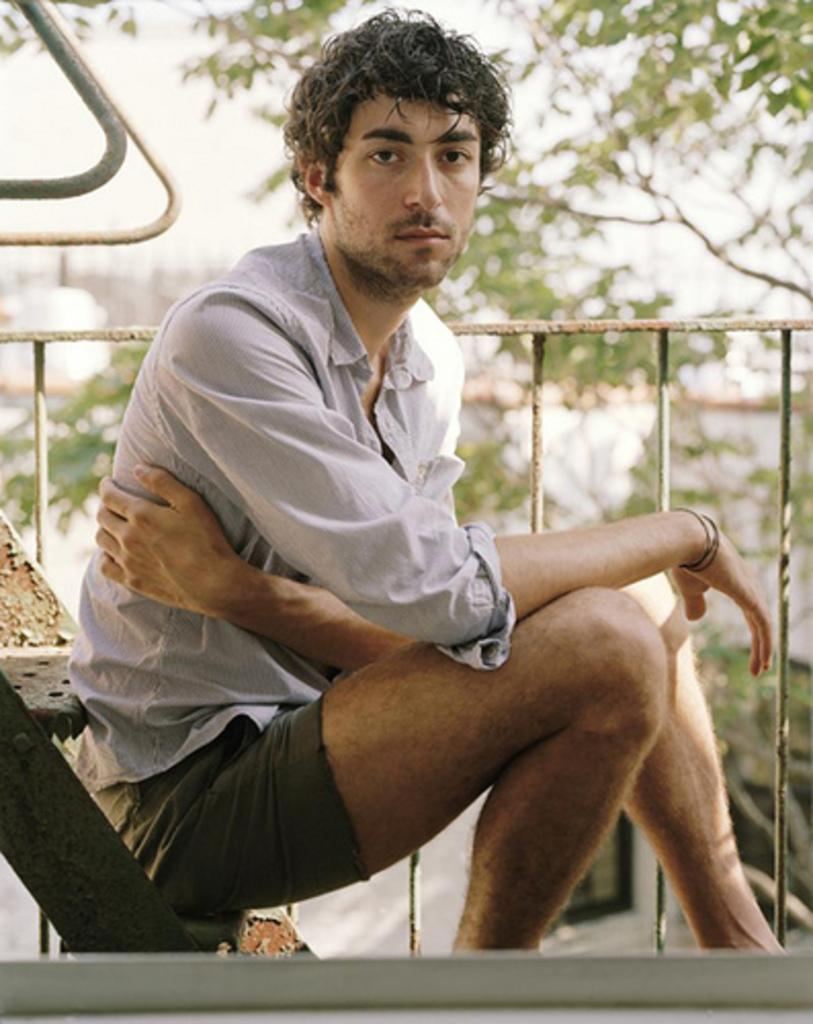Who is the main subject in the image? There is a boy in the center of the image. What is behind the boy in the image? There is a boundary behind the boy. What can be seen in the distance in the image? There are trees in the background of the image. What type of building can be seen in the image? There is no building present in the image; it features a boy with a boundary and trees in the background. 